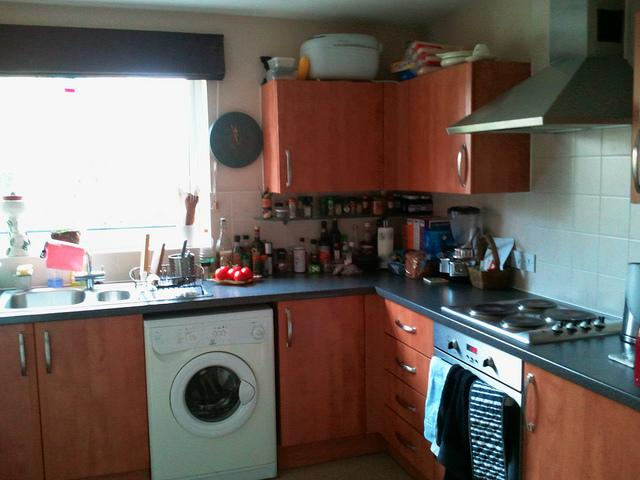What material is the sink made of?

Choices:
A) wood
B) plastic
C) stainless steel
D) porcelain stainless steel 